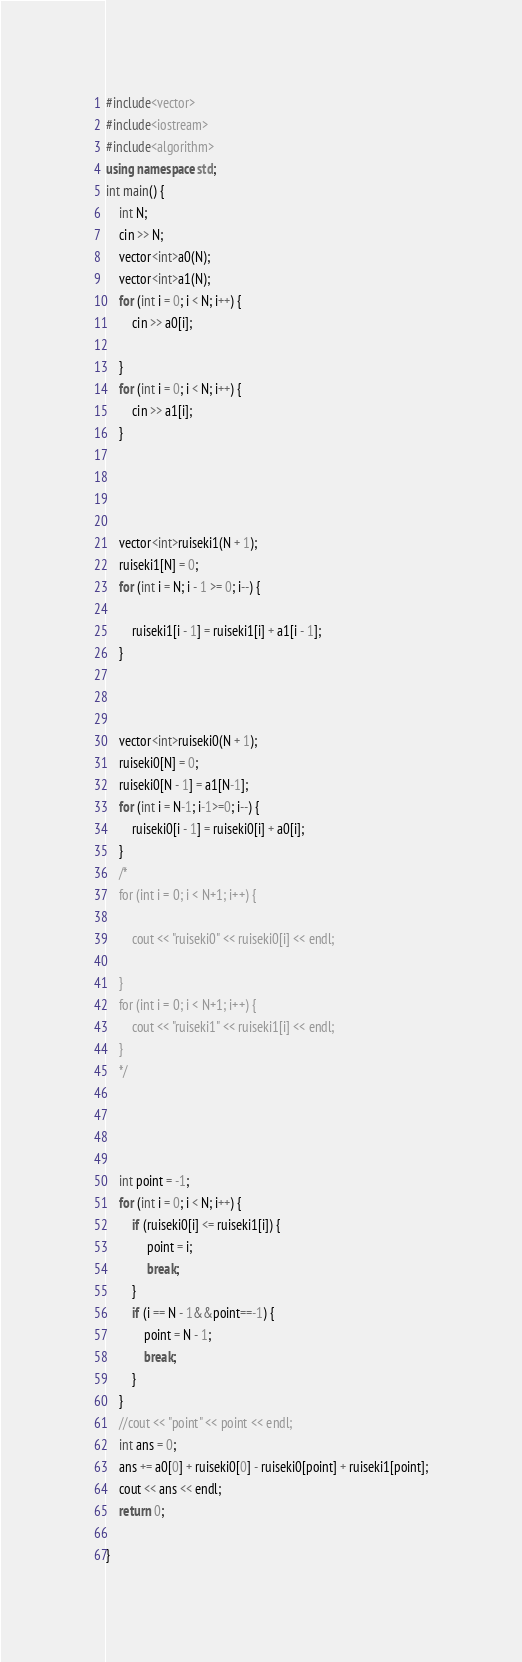<code> <loc_0><loc_0><loc_500><loc_500><_C++_>#include<vector>
#include<iostream>
#include<algorithm>
using namespace std;
int main() {
	int N;
	cin >> N;
	vector<int>a0(N);
	vector<int>a1(N);
	for (int i = 0; i < N; i++) {
		cin >> a0[i];
		
	}
	for (int i = 0; i < N; i++) {
		cin >> a1[i];
	}




	vector<int>ruiseki1(N + 1);
	ruiseki1[N] = 0;
	for (int i = N; i - 1 >= 0; i--) {

		ruiseki1[i - 1] = ruiseki1[i] + a1[i - 1];
	}



	vector<int>ruiseki0(N + 1);
	ruiseki0[N] = 0;
	ruiseki0[N - 1] = a1[N-1];
	for (int i = N-1; i-1>=0; i--) {
		ruiseki0[i - 1] = ruiseki0[i] + a0[i];
	}
	/*
	for (int i = 0; i < N+1; i++) {

		cout << "ruiseki0" << ruiseki0[i] << endl;
		
	}
	for (int i = 0; i < N+1; i++) {
		cout << "ruiseki1" << ruiseki1[i] << endl;
	}
	*/




	int point = -1;
	for (int i = 0; i < N; i++) {
		if (ruiseki0[i] <= ruiseki1[i]) {
			 point = i;
			 break;
		}
		if (i == N - 1&&point==-1) {
			point = N - 1;
			break;
		}
	}
	//cout << "point" << point << endl;
	int ans = 0;
	ans += a0[0] + ruiseki0[0] - ruiseki0[point] + ruiseki1[point];
	cout << ans << endl;
	return 0;

}</code> 